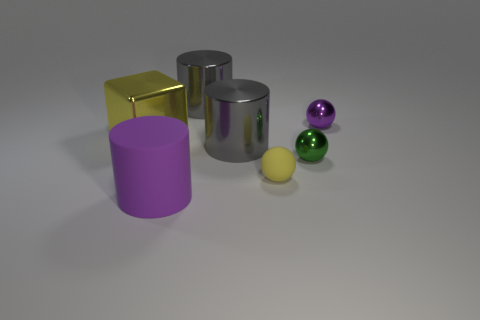Add 3 big cyan matte things. How many objects exist? 10 Subtract all gray metallic cylinders. How many cylinders are left? 1 Subtract all gray spheres. How many gray cylinders are left? 2 Subtract all cylinders. How many objects are left? 4 Subtract all blue matte balls. Subtract all big metallic cylinders. How many objects are left? 5 Add 1 big yellow metallic objects. How many big yellow metallic objects are left? 2 Add 6 large brown things. How many large brown things exist? 6 Subtract 0 red cylinders. How many objects are left? 7 Subtract all green cubes. Subtract all blue spheres. How many cubes are left? 1 